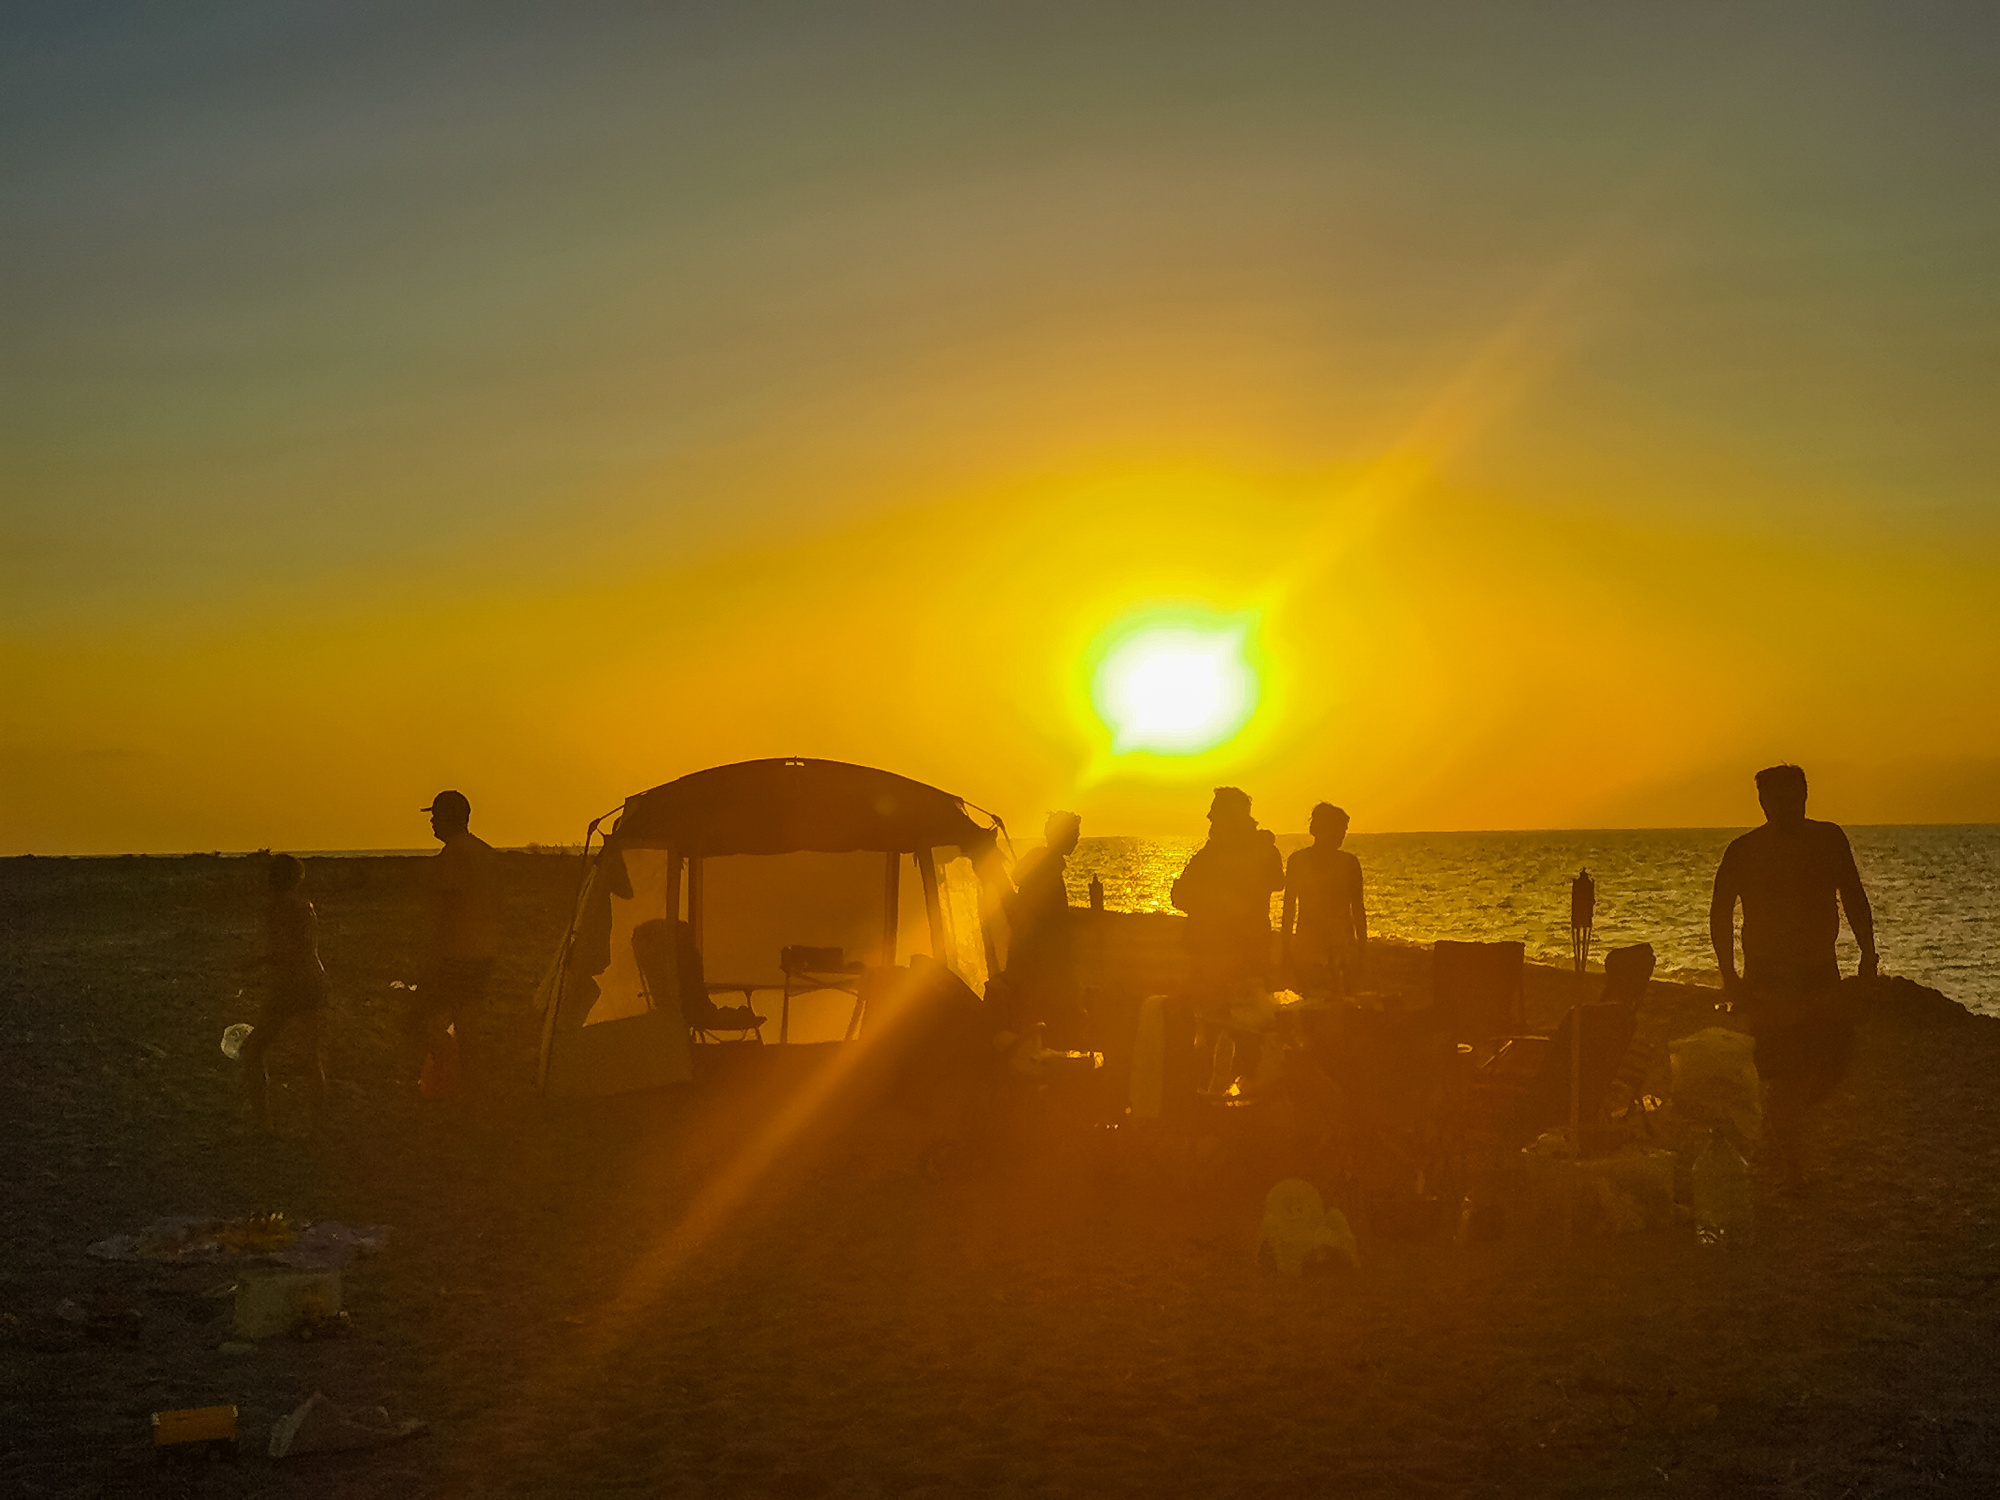What do you see happening in this image?
 The image captures a serene scene of a group of people gathered on a beach at sunset. The sun is gracefully setting over the horizon, painting the sky with hues of orange. The group of people are huddled around a small tent, their figures silhouetted against the warm glow of the sunset. Various items are scattered around the beach, hinting at a day spent in leisure and enjoyment. The photo is taken from a distance, providing a panoramic view of the beach and the people, with the setting sun as a breathtaking backdrop. The landmark information 'sa_1212' does not provide any additional details about the location of this beach. 